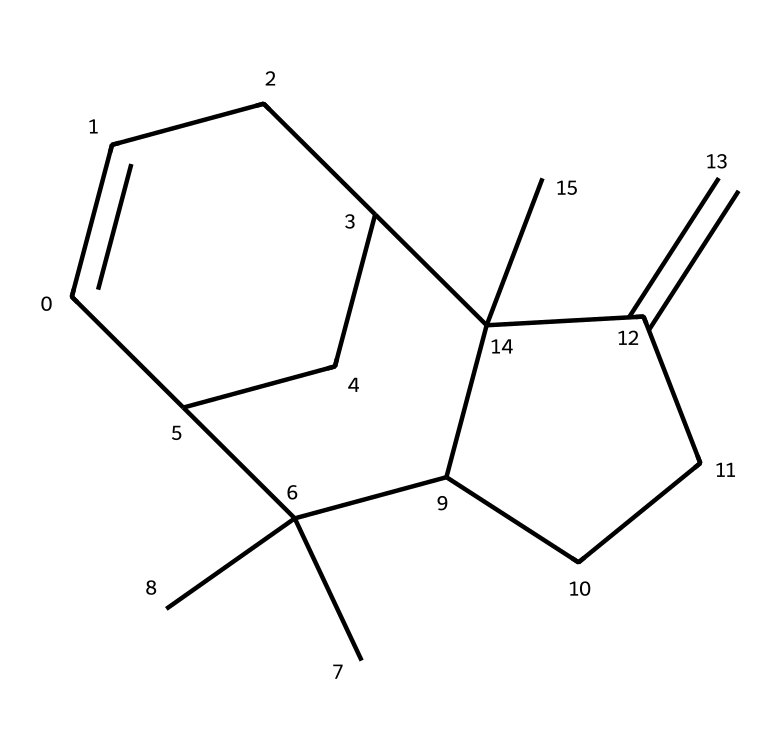What is the molecular formula of caryophyllene? To find the molecular formula, we count the number of each type of atom in the provided SMILES. For caryophyllene, there are 15 carbon atoms (C) and 24 hydrogen atoms (H), leading to the molecular formula C15H24.
Answer: C15H24 How many rings are present in the structure of caryophyllene? By examining the structure, we can see that there are two distinctive ring systems in caryophyllene. One consists of five carbons, and the other contains three. Therefore, caryophyllene has two rings.
Answer: 2 Which element is predominantly present in caryophyllene? Analyzing the structural formula, we observe that carbon atoms are present in the highest quantity compared to others. Carbon atoms are fundamental in organic compounds like terpenes.
Answer: carbon What type of compound is caryophyllene? Caryophyllene is classified as a terpene, which is a type of hydrocarbon commonly found in essential oils and plants. The presence of multiple carbon rings is characteristic of this chemical family.
Answer: terpene Is caryophyllene a saturated or unsaturated compound? The presence of double bonds in the structure, indicated by the=C notation, shows that caryophyllene has carbon-carbon double bonds. This means it is an unsaturated compound.
Answer: unsaturated How many double bonds are present in caryophyllene? In the structure of caryophyllene, there is one identifiable double bond seen from the “C=C” notation. Thus, it features one double bond.
Answer: 1 Does caryophyllene have any functional groups? Upon analyzing the structure, there are no specific functional groups such as alcohols, ketones, or acids; its structure is primarily composed of carbon and hydrogen without any heteroatoms. Therefore, it does not have recognizable functional groups.
Answer: no 